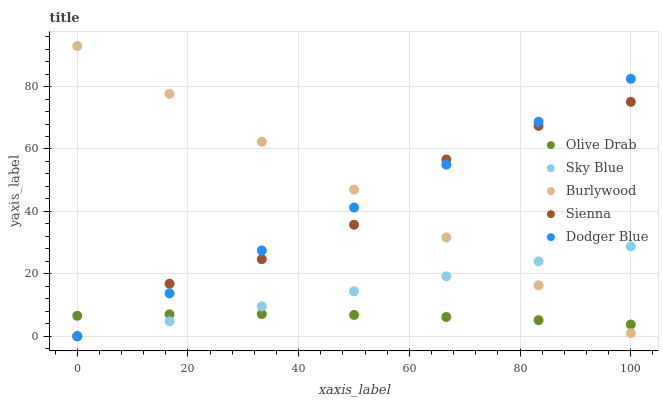Does Olive Drab have the minimum area under the curve?
Answer yes or no. Yes. Does Burlywood have the maximum area under the curve?
Answer yes or no. Yes. Does Sky Blue have the minimum area under the curve?
Answer yes or no. No. Does Sky Blue have the maximum area under the curve?
Answer yes or no. No. Is Dodger Blue the smoothest?
Answer yes or no. Yes. Is Sienna the roughest?
Answer yes or no. Yes. Is Sky Blue the smoothest?
Answer yes or no. No. Is Sky Blue the roughest?
Answer yes or no. No. Does Sky Blue have the lowest value?
Answer yes or no. Yes. Does Olive Drab have the lowest value?
Answer yes or no. No. Does Burlywood have the highest value?
Answer yes or no. Yes. Does Sky Blue have the highest value?
Answer yes or no. No. Does Sky Blue intersect Olive Drab?
Answer yes or no. Yes. Is Sky Blue less than Olive Drab?
Answer yes or no. No. Is Sky Blue greater than Olive Drab?
Answer yes or no. No. 